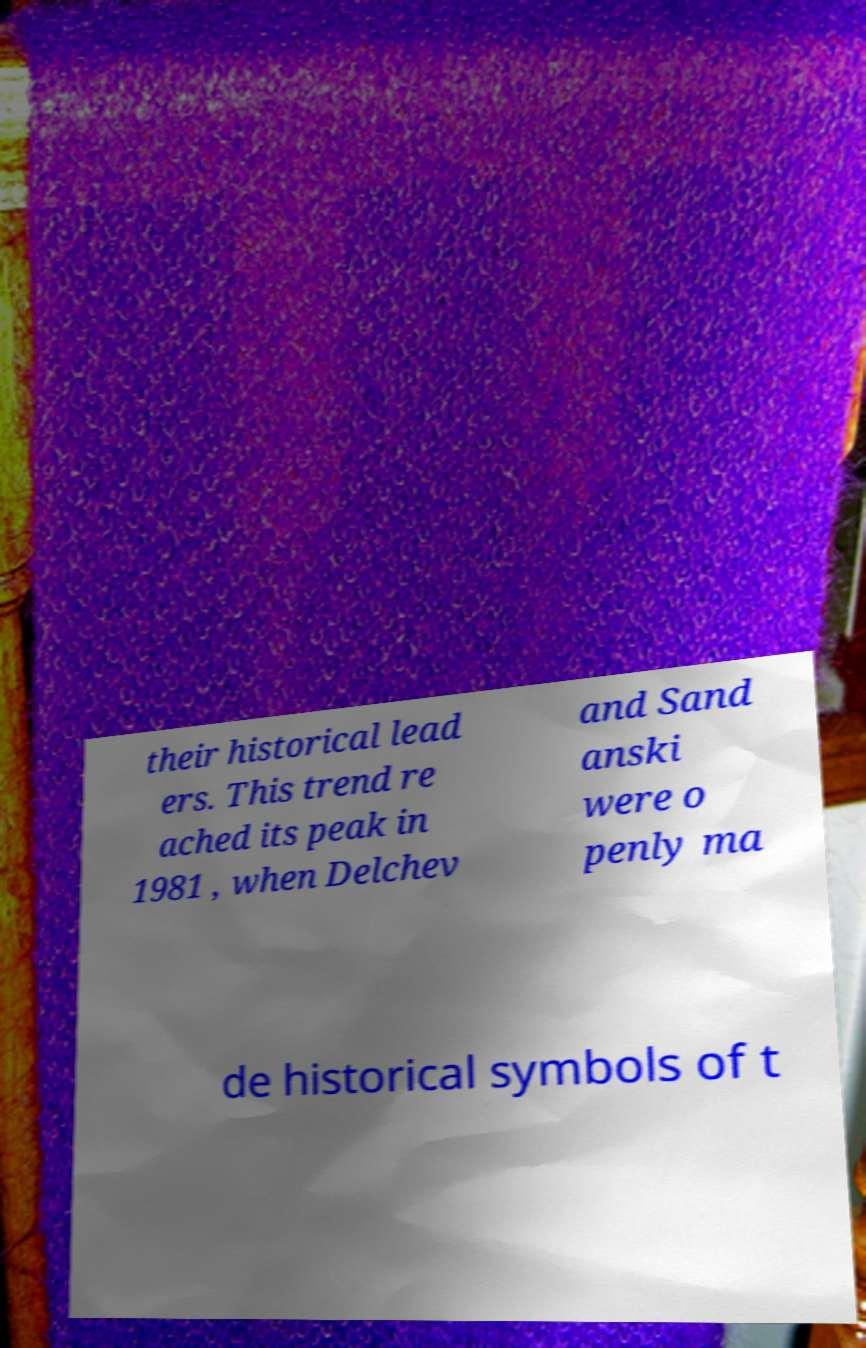I need the written content from this picture converted into text. Can you do that? their historical lead ers. This trend re ached its peak in 1981 , when Delchev and Sand anski were o penly ma de historical symbols of t 